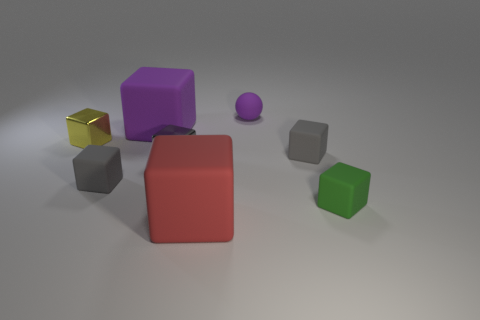Does the purple object that is in front of the purple rubber ball have the same size as the red rubber object?
Give a very brief answer. Yes. Are there any large matte objects of the same color as the small matte ball?
Your response must be concise. Yes. Are there any rubber spheres that are on the left side of the gray rubber cube that is on the left side of the purple matte cube?
Provide a short and direct response. No. Are there any gray cubes made of the same material as the yellow object?
Your answer should be very brief. Yes. The tiny cube that is behind the tiny gray rubber block that is to the right of the small purple thing is made of what material?
Your answer should be very brief. Metal. There is a tiny thing that is behind the gray metallic object and on the left side of the purple ball; what is it made of?
Make the answer very short. Metal. Are there the same number of large purple rubber cubes that are to the left of the small yellow thing and large brown metal objects?
Keep it short and to the point. Yes. What number of tiny gray rubber objects have the same shape as the small green rubber object?
Your answer should be compact. 2. What is the size of the matte block behind the small gray block right of the big rubber block in front of the small green rubber block?
Provide a short and direct response. Large. Is the material of the big cube that is in front of the tiny gray metal cube the same as the tiny purple ball?
Provide a short and direct response. Yes. 